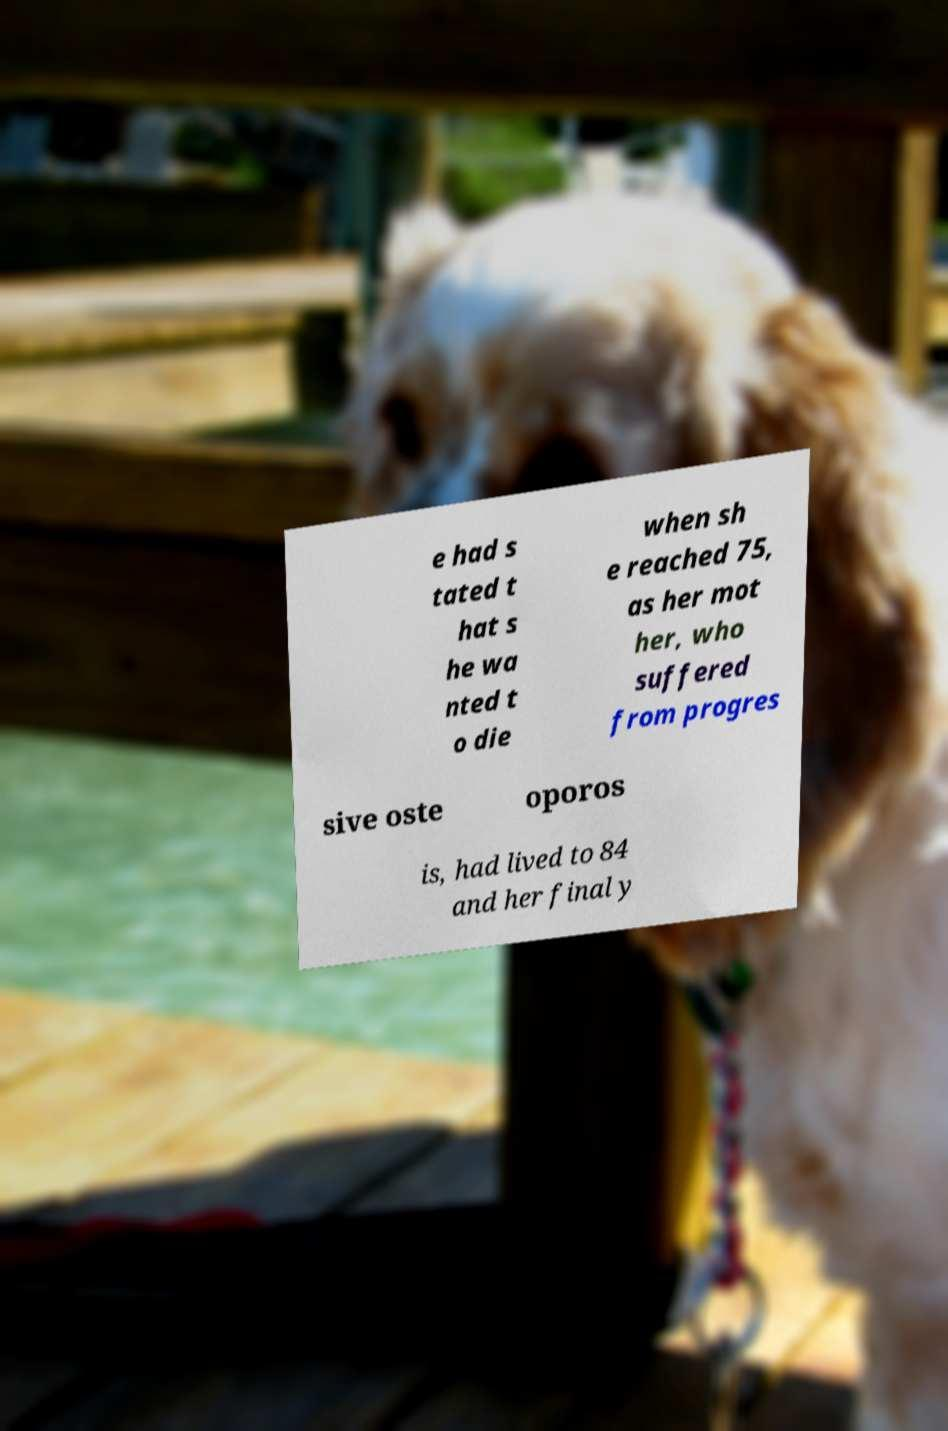I need the written content from this picture converted into text. Can you do that? e had s tated t hat s he wa nted t o die when sh e reached 75, as her mot her, who suffered from progres sive oste oporos is, had lived to 84 and her final y 